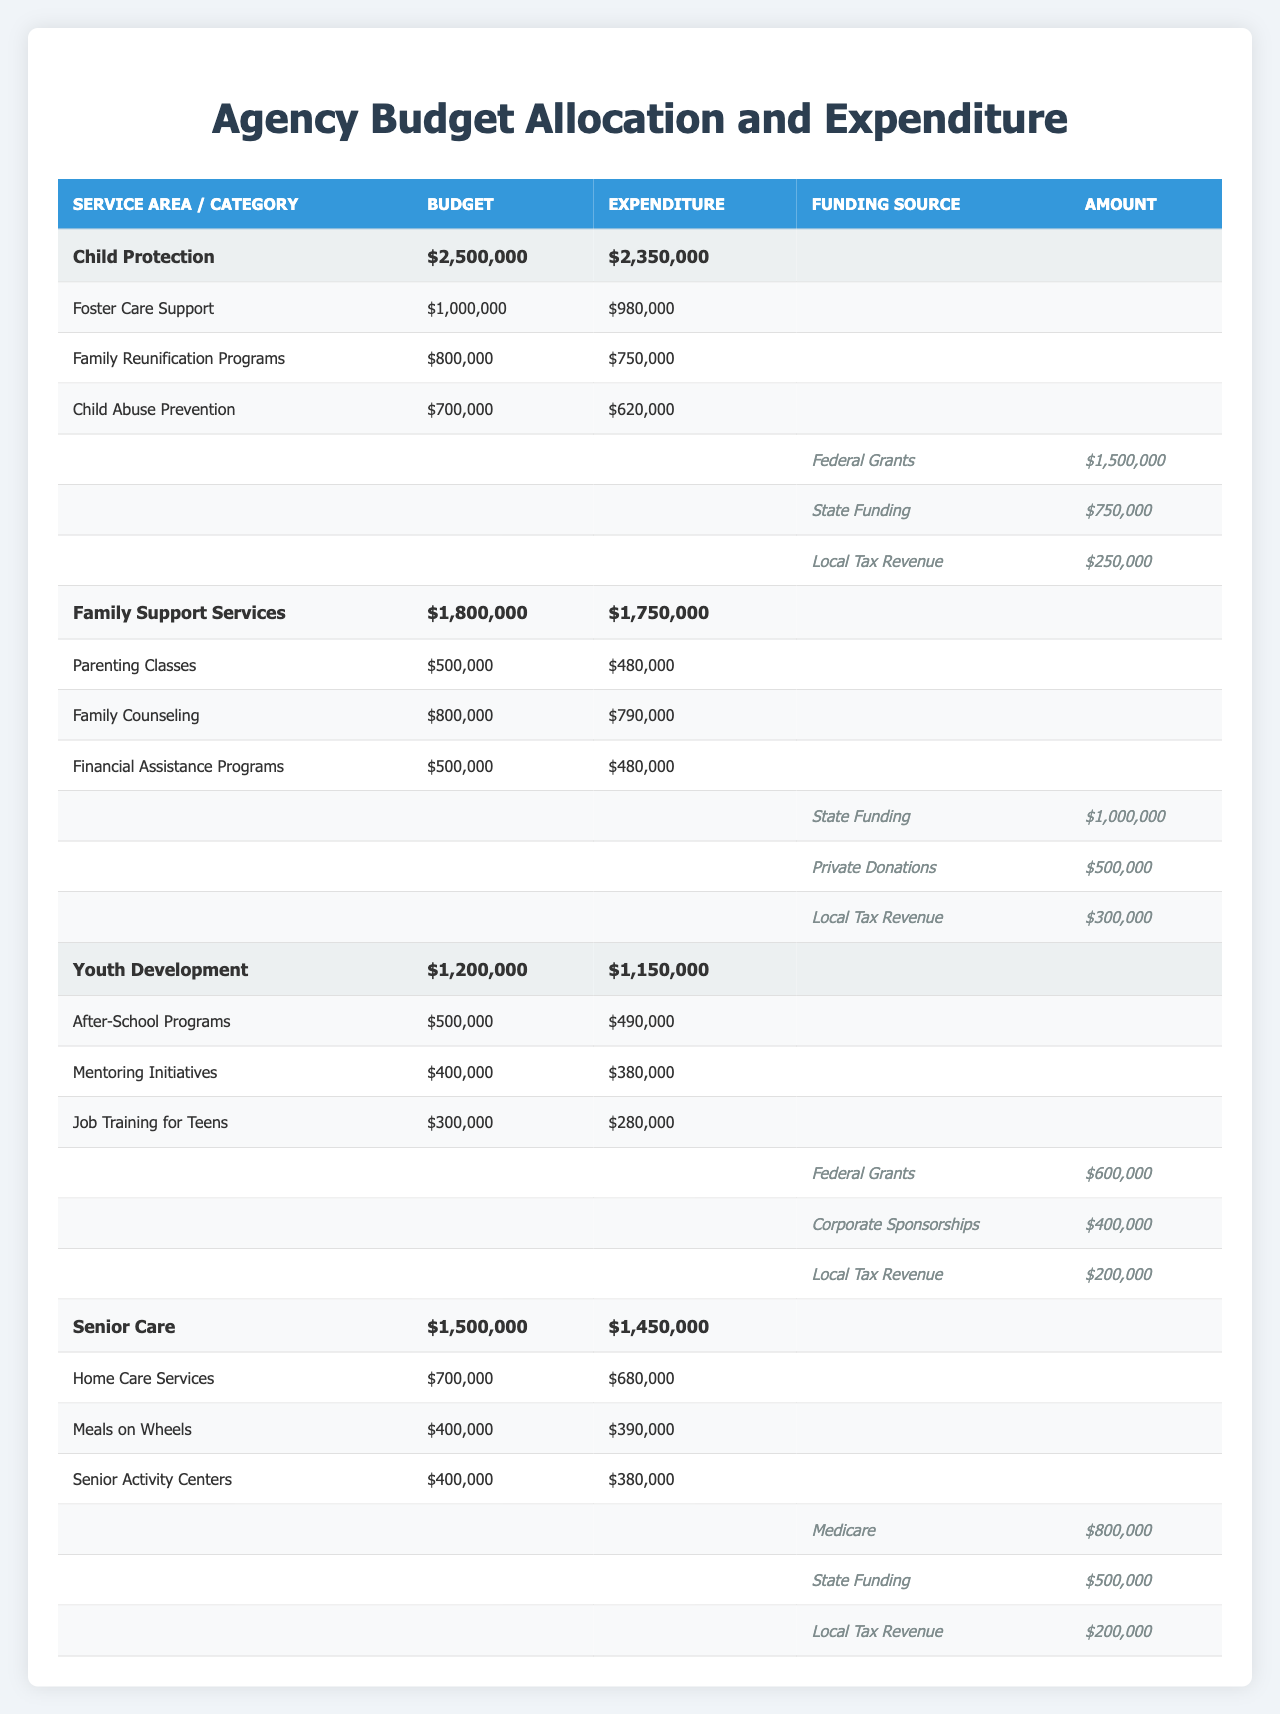What is the total budget allocated for the Child Protection service area? The total budget for the Child Protection service area is listed in the table as $2,500,000.
Answer: $2,500,000 What is the expenditure amount for Family Support Services? The expenditure for Family Support Services is shown in the table as $1,750,000.
Answer: $1,750,000 How much funding comes from Federal Grants for Youth Development? The table provides the amount from Federal Grants for Youth Development as $600,000.
Answer: $600,000 Which sub-category under Senior Care has the lowest expenditure? Examining the sub-categories under Senior Care, "Senior Activity Centers" has the lowest expenditure of $380,000.
Answer: Senior Activity Centers What is the total funding from Local Tax Revenue across all service areas? Adding the Local Tax Revenue amounts: Child Protection ($250,000) + Family Support Services ($300,000) + Youth Development ($200,000) + Senior Care ($200,000) totals to $950,000.
Answer: $950,000 Is the expenditure for Foster Care Support less than its budget? The expenditure for Foster Care Support is $980,000 while the budget is $1,000,000, so the expenditure is indeed less than the budget.
Answer: Yes What percentage of the total budget for Child Protection was used? The percentage used can be calculated as (Expenditure / Total Budget) * 100, which is ($2,350,000 / $2,500,000) * 100 = 94%.
Answer: 94% If we combine the budgets for all the sub-categories under Family Support Services, what is the total? Adding the budgets: Parenting Classes ($500,000) + Family Counseling ($800,000) + Financial Assistance Programs ($500,000) gives a total budget of $1,800,000.
Answer: $1,800,000 What is the difference between total expenditure and total budget for Youth Development? The difference can be calculated by subtracting the total expenditure ($1,150,000) from the total budget ($1,200,000), which results in a difference of $50,000.
Answer: $50,000 Which funding source contributes the most to the Senior Care service area? The table indicates that Medicare contributes the most to Senior Care, amounting to $800,000.
Answer: Medicare 